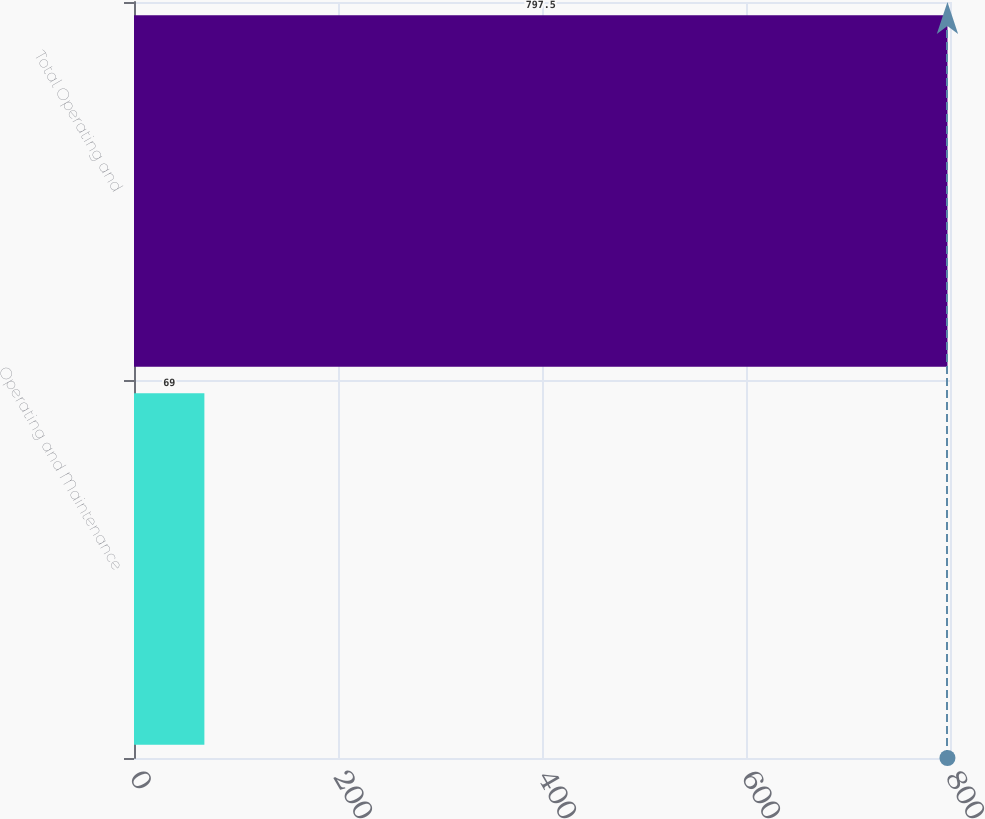Convert chart to OTSL. <chart><loc_0><loc_0><loc_500><loc_500><bar_chart><fcel>Operating and Maintenance<fcel>Total Operating and<nl><fcel>69<fcel>797.5<nl></chart> 